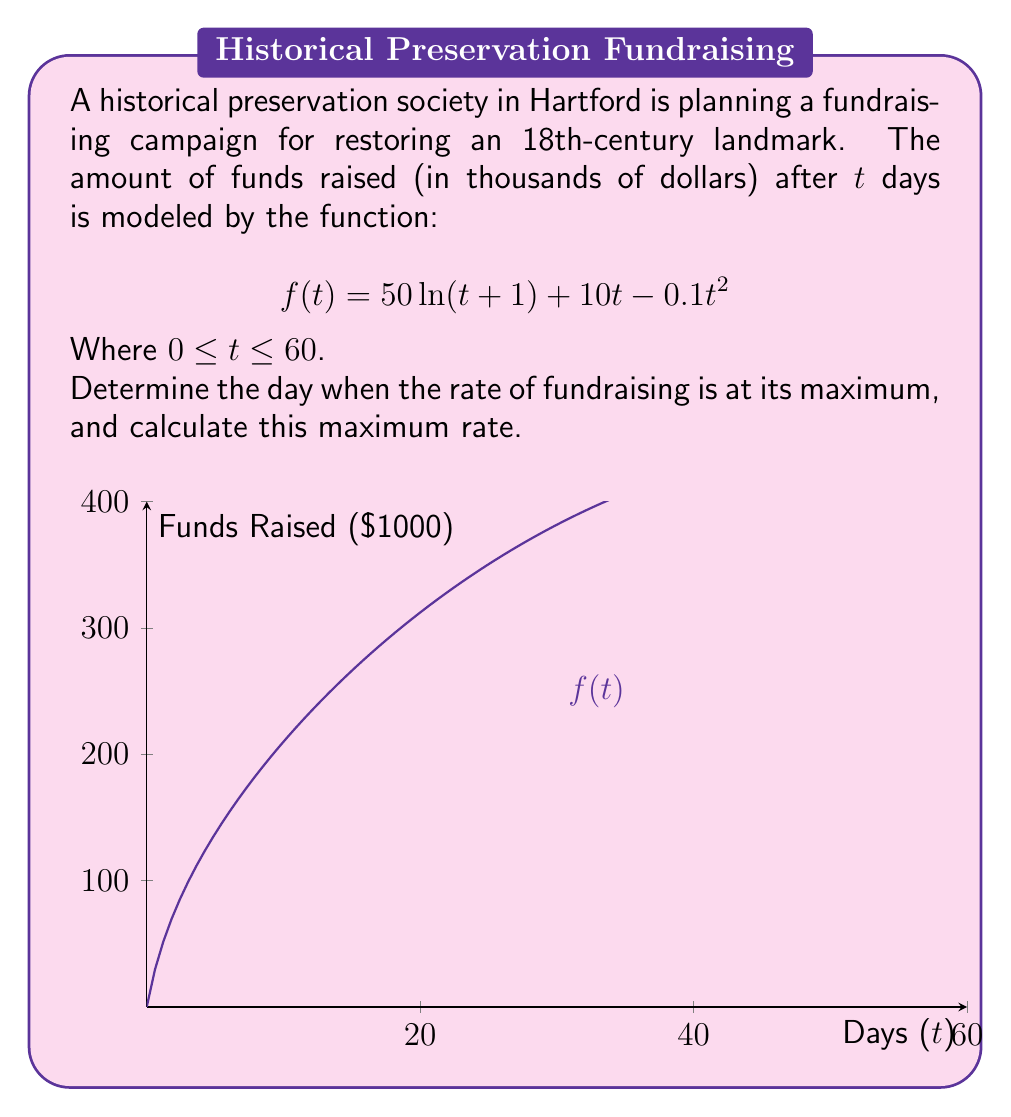Provide a solution to this math problem. To solve this problem, we'll follow these steps:

1) The rate of fundraising is given by the derivative of $f(t)$. Let's find $f'(t)$:

   $$f'(t) = \frac{50}{t+1} + 10 - 0.2t$$

2) To find the maximum rate, we need to find where $f''(t) = 0$:

   $$f''(t) = -\frac{50}{(t+1)^2} - 0.2$$

3) Set $f''(t) = 0$ and solve for $t$:

   $$-\frac{50}{(t+1)^2} - 0.2 = 0$$
   $$-\frac{50}{(t+1)^2} = 0.2$$
   $$\frac{50}{(t+1)^2} = 0.2$$
   $$(t+1)^2 = \frac{50}{0.2} = 250$$
   $$t+1 = \sqrt{250} = 5\sqrt{10}$$
   $$t = 5\sqrt{10} - 1 \approx 14.83$$

4) Since $t$ represents days, we round to the nearest whole number: $t = 15$ days.

5) To find the maximum rate, we substitute $t = 15$ into $f'(t)$:

   $$f'(15) = \frac{50}{15+1} + 10 - 0.2(15) = \frac{50}{16} + 10 - 3 = 3.125 + 7 = 10.125$$

Therefore, the rate of fundraising is at its maximum on day 15, and the maximum rate is $10.125 thousand dollars per day.
Answer: Day 15; $10.125 thousand/day 